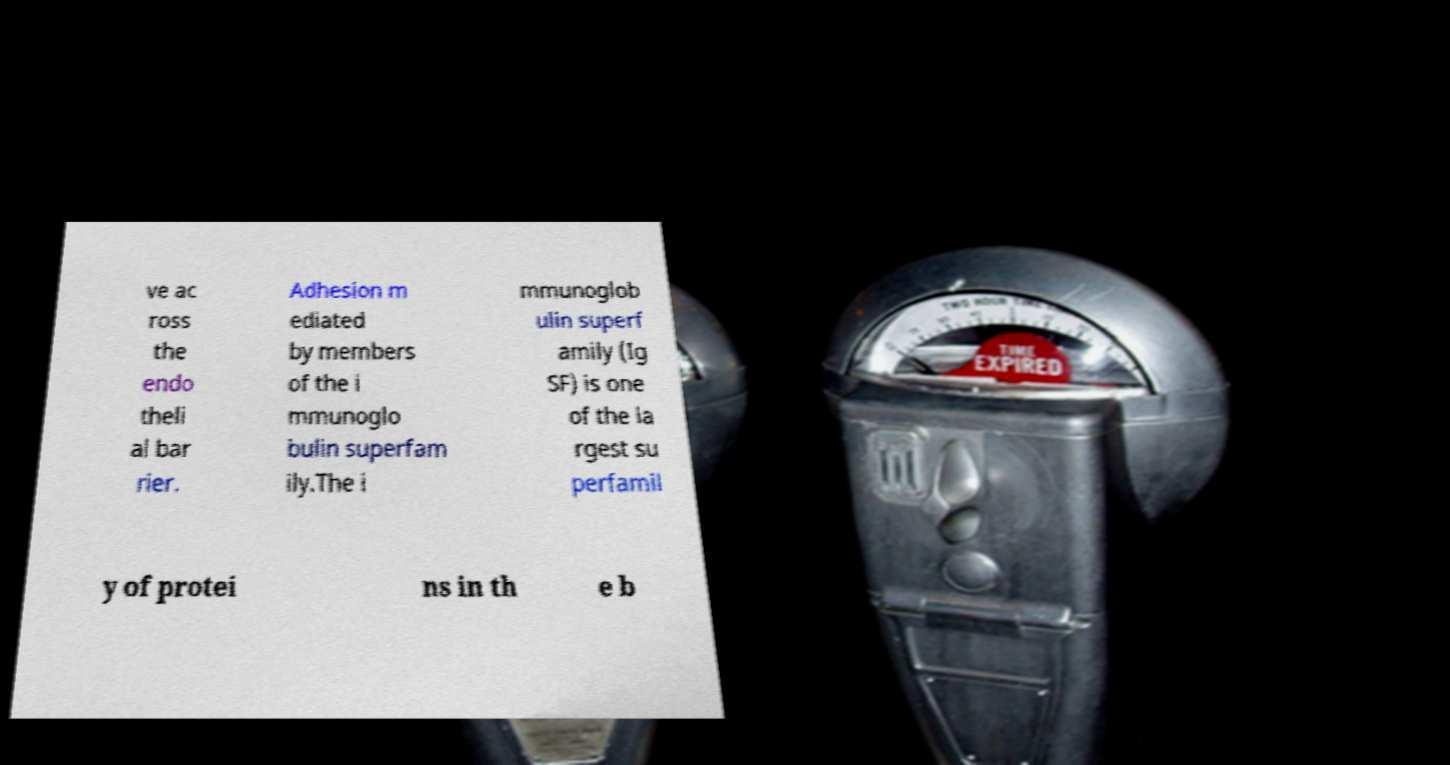Could you extract and type out the text from this image? ve ac ross the endo theli al bar rier. Adhesion m ediated by members of the i mmunoglo bulin superfam ily.The i mmunoglob ulin superf amily (Ig SF) is one of the la rgest su perfamil y of protei ns in th e b 